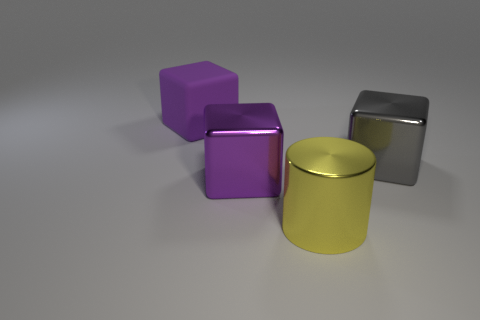How many matte things are large yellow objects or large blocks?
Ensure brevity in your answer.  1. What number of big purple blocks are in front of the large gray object?
Offer a terse response. 1. Are there any metal objects that have the same size as the purple shiny block?
Your response must be concise. Yes. Is there a tiny matte block of the same color as the matte thing?
Your response must be concise. No. Are there any other things that have the same size as the purple matte object?
Your answer should be very brief. Yes. What number of large shiny blocks are the same color as the big cylinder?
Your answer should be very brief. 0. Does the rubber cube have the same color as the metal object that is on the left side of the big yellow metallic thing?
Your answer should be very brief. Yes. What number of objects are big yellow cylinders or things left of the large purple metal block?
Ensure brevity in your answer.  2. There is a purple thing that is in front of the purple matte cube that is behind the gray metallic block; how big is it?
Your answer should be compact. Large. Is the number of large yellow shiny objects that are to the right of the gray thing the same as the number of big purple matte things right of the large yellow metallic cylinder?
Ensure brevity in your answer.  Yes. 